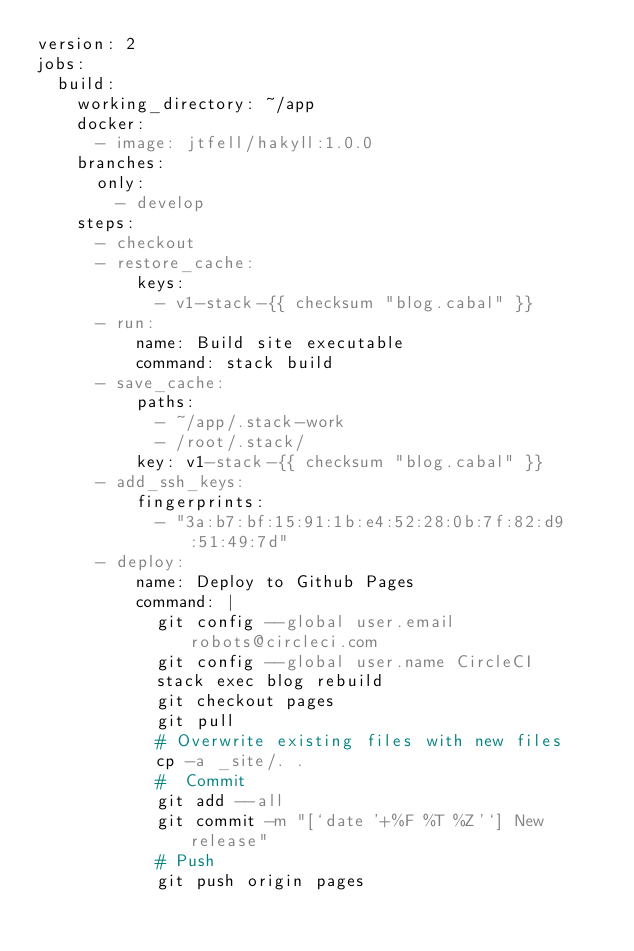Convert code to text. <code><loc_0><loc_0><loc_500><loc_500><_YAML_>version: 2
jobs:
  build:
    working_directory: ~/app
    docker:
      - image: jtfell/hakyll:1.0.0
    branches:
      only:
        - develop
    steps:
      - checkout
      - restore_cache:
          keys:
            - v1-stack-{{ checksum "blog.cabal" }}
      - run:
          name: Build site executable
          command: stack build
      - save_cache:
          paths:
            - ~/app/.stack-work
            - /root/.stack/
          key: v1-stack-{{ checksum "blog.cabal" }}
      - add_ssh_keys:
          fingerprints:
            - "3a:b7:bf:15:91:1b:e4:52:28:0b:7f:82:d9:51:49:7d"
      - deploy:
          name: Deploy to Github Pages
          command: |
            git config --global user.email robots@circleci.com
            git config --global user.name CircleCI
            stack exec blog rebuild
            git checkout pages
            git pull
            # Overwrite existing files with new files
            cp -a _site/. .
            #  Commit
            git add --all
            git commit -m "[`date '+%F %T %Z'`] New release"
            # Push
            git push origin pages

</code> 